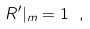Convert formula to latex. <formula><loc_0><loc_0><loc_500><loc_500>R ^ { \prime } | _ { m } = 1 \ ,</formula> 